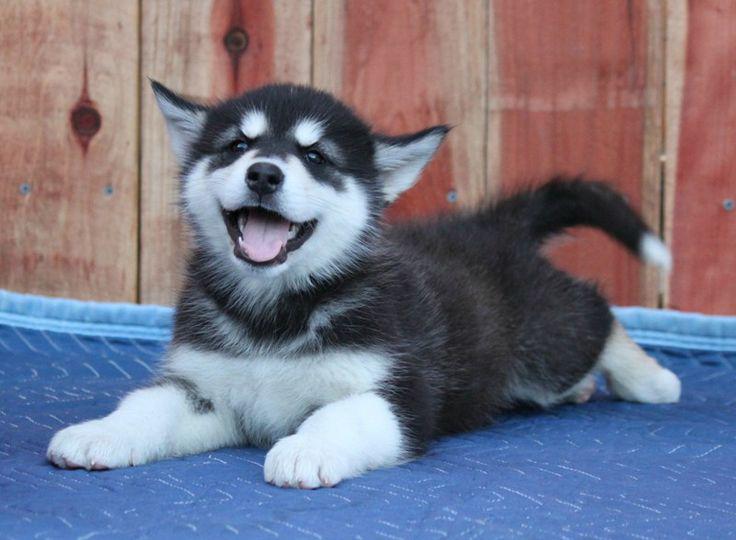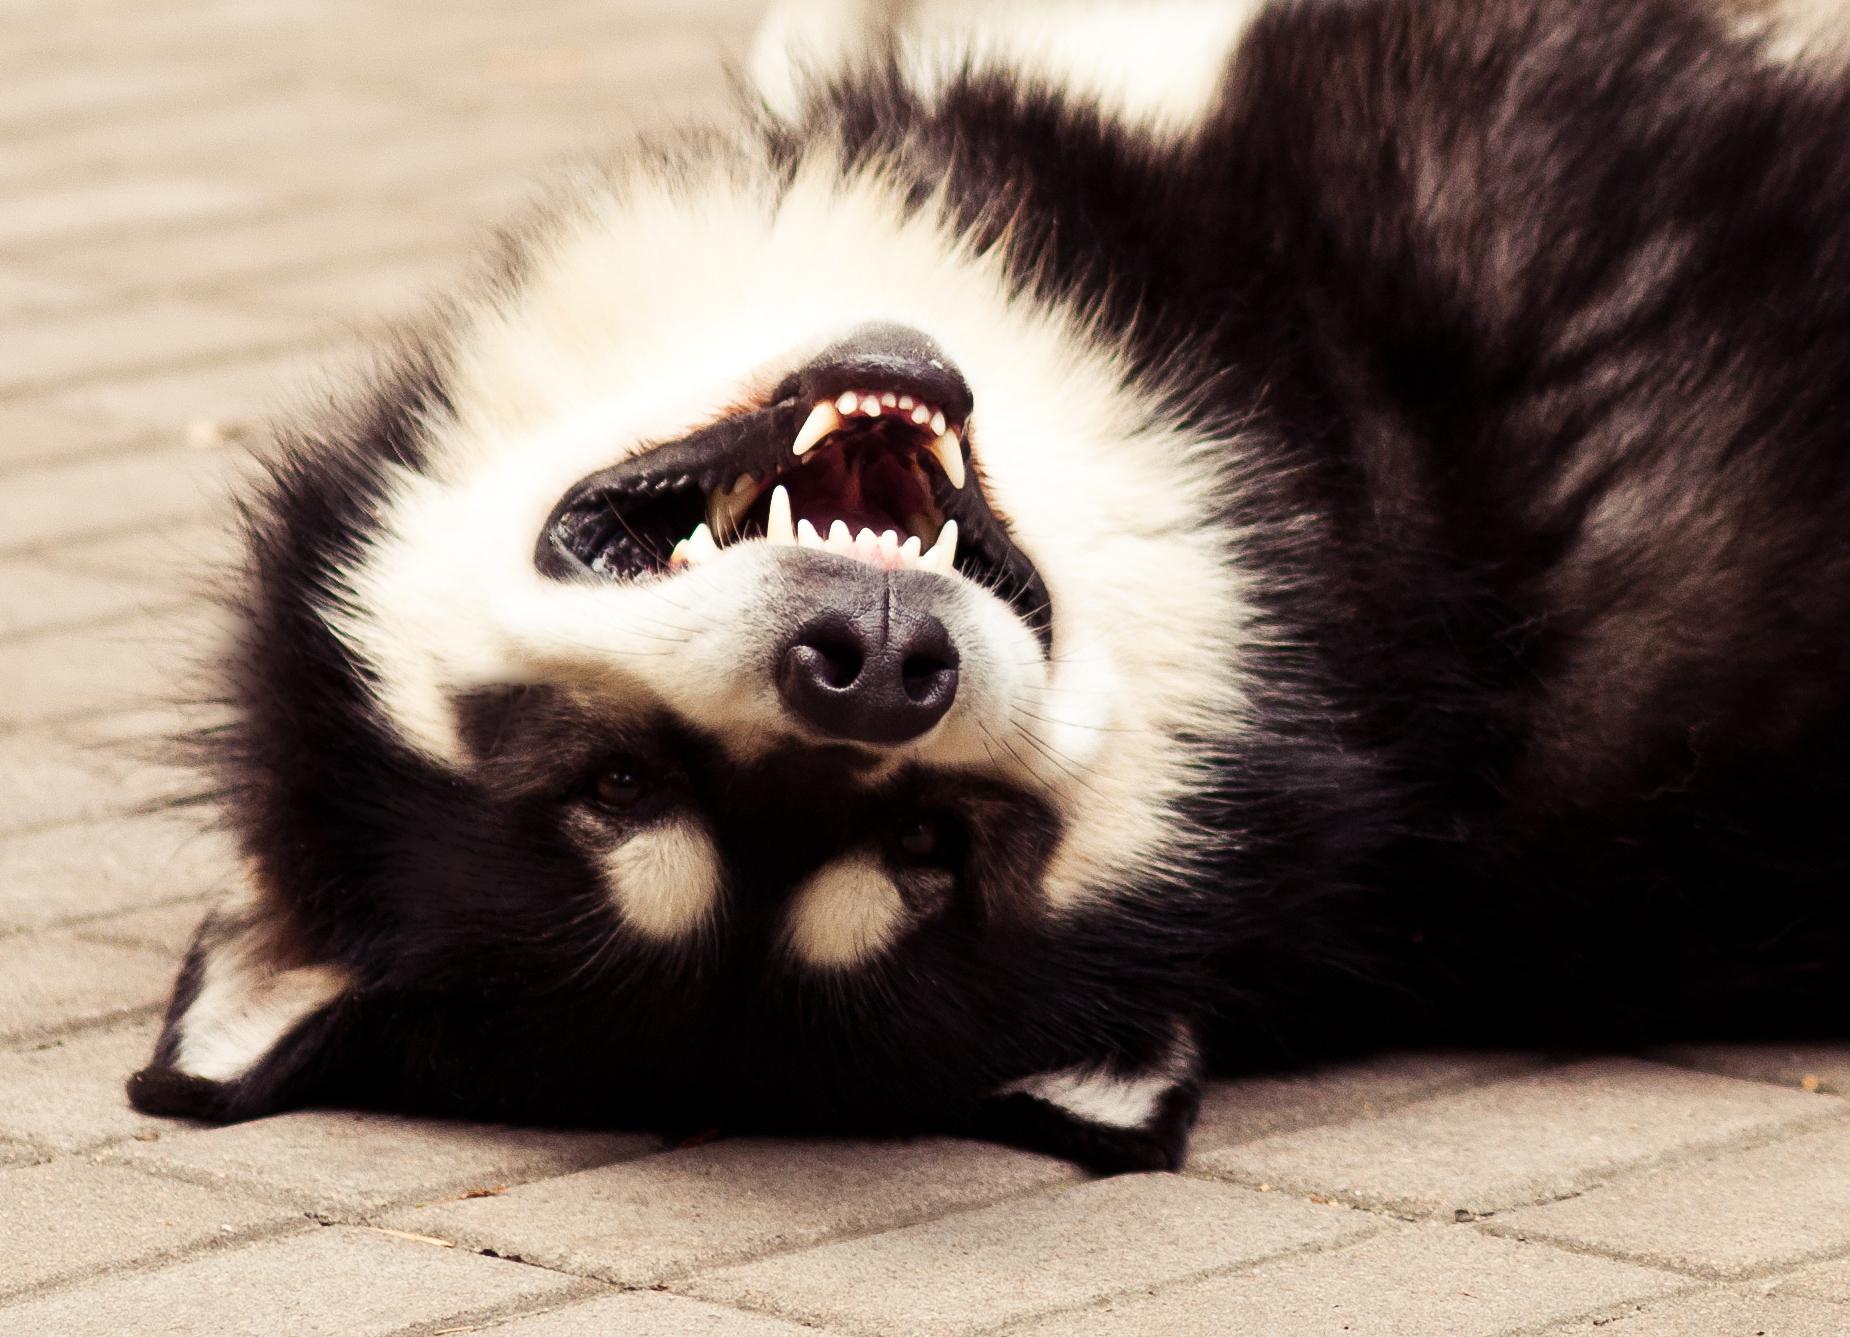The first image is the image on the left, the second image is the image on the right. Considering the images on both sides, is "Each image includes a black-and-white husky with an open mouth, and at least one image includes a dog reclining on its belly with its front paws extended." valid? Answer yes or no. Yes. The first image is the image on the left, the second image is the image on the right. Evaluate the accuracy of this statement regarding the images: "A dog is sitting.". Is it true? Answer yes or no. No. 